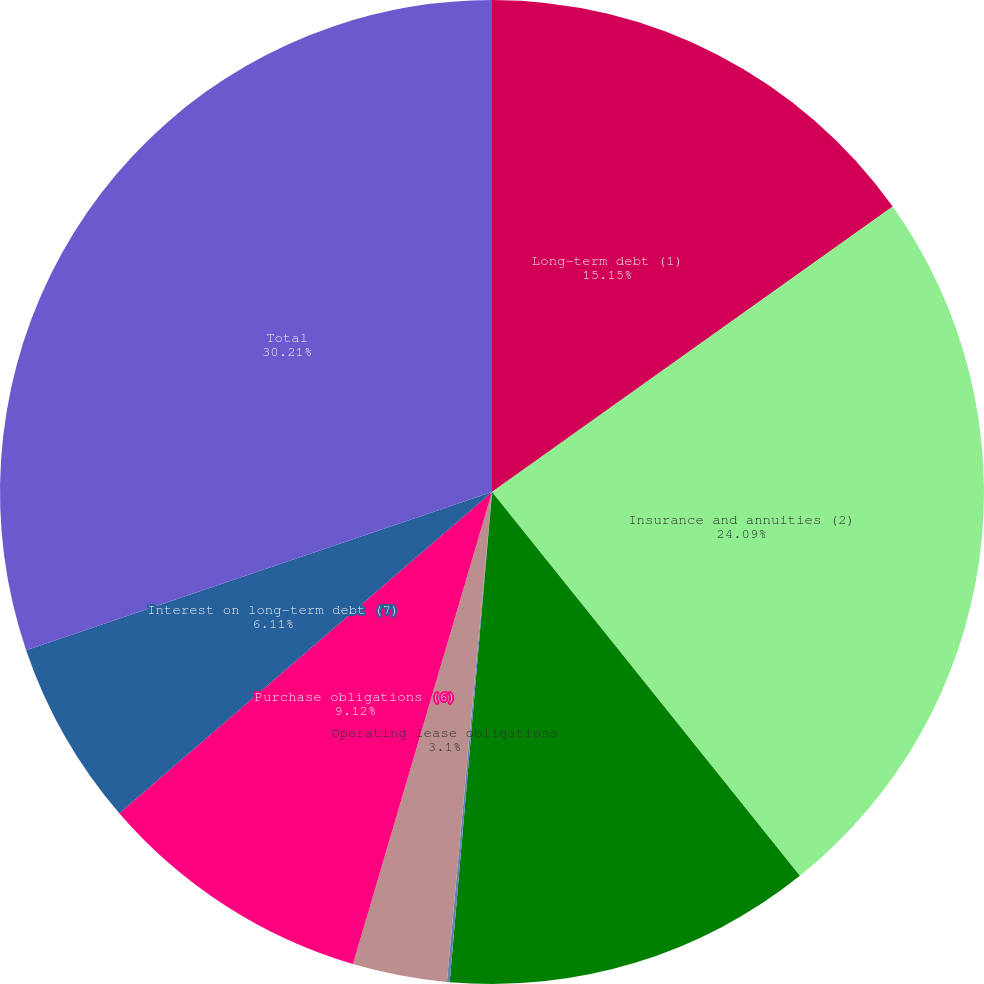Convert chart to OTSL. <chart><loc_0><loc_0><loc_500><loc_500><pie_chart><fcel>Long-term debt (1)<fcel>Insurance and annuities (2)<fcel>Deferred premium options (4)<fcel>Affordable housing and other<fcel>Operating lease obligations<fcel>Purchase obligations (6)<fcel>Interest on long-term debt (7)<fcel>Total<nl><fcel>15.15%<fcel>24.09%<fcel>12.13%<fcel>0.09%<fcel>3.1%<fcel>9.12%<fcel>6.11%<fcel>30.21%<nl></chart> 